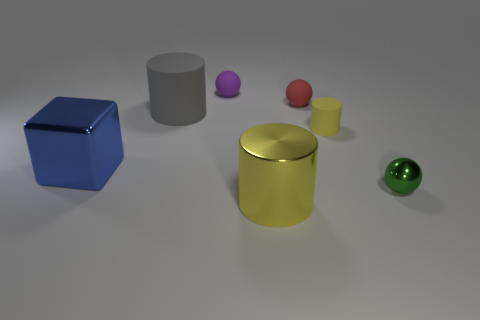Can you describe the shapes and relative sizes of the objects? Certainly! From left to right, there's a large blue cube, a medium-sized gray cylinder, a small purple sphere, a small pink sphere, a small red sphere, a large yellow cylinder, and a medium-sized green sphere. The size order is 'large', 'medium', and 'small'.  Which object seems the closest to the point of view? The yellow cylinder appears to be the closest to the point of view based on its size and placement in the image. 